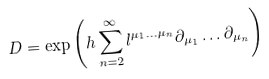<formula> <loc_0><loc_0><loc_500><loc_500>D = \exp \left ( h \sum _ { n = 2 } ^ { \infty } l ^ { \mu _ { 1 } \dots \mu _ { n } } \partial _ { \mu _ { 1 } } \dots \partial _ { \mu _ { n } } \right )</formula> 